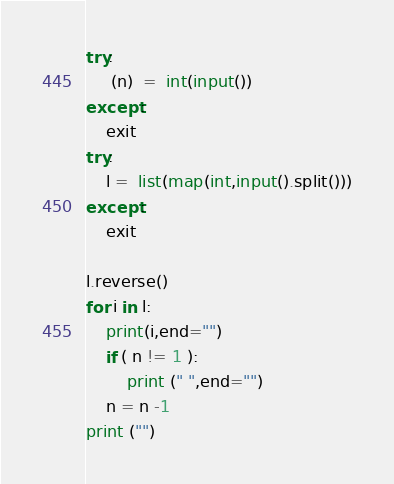Convert code to text. <code><loc_0><loc_0><loc_500><loc_500><_Python_>try:
     (n)  =  int(input())
except:
    exit
try:
    l =  list(map(int,input().split()))
except:
    exit

l.reverse()
for i in l:
    print(i,end="")
    if ( n != 1 ):
        print (" ",end="")
    n = n -1
print ("")

</code> 